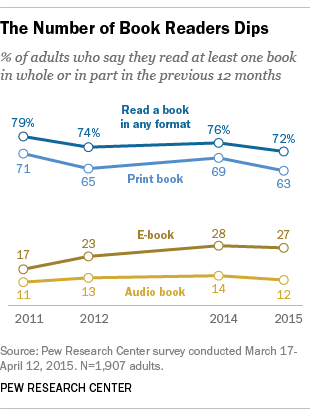Highlight a few significant elements in this photo. The average of all values above 75 is approximately 77.5. In 2014, 69% of adults reported reading print books. 